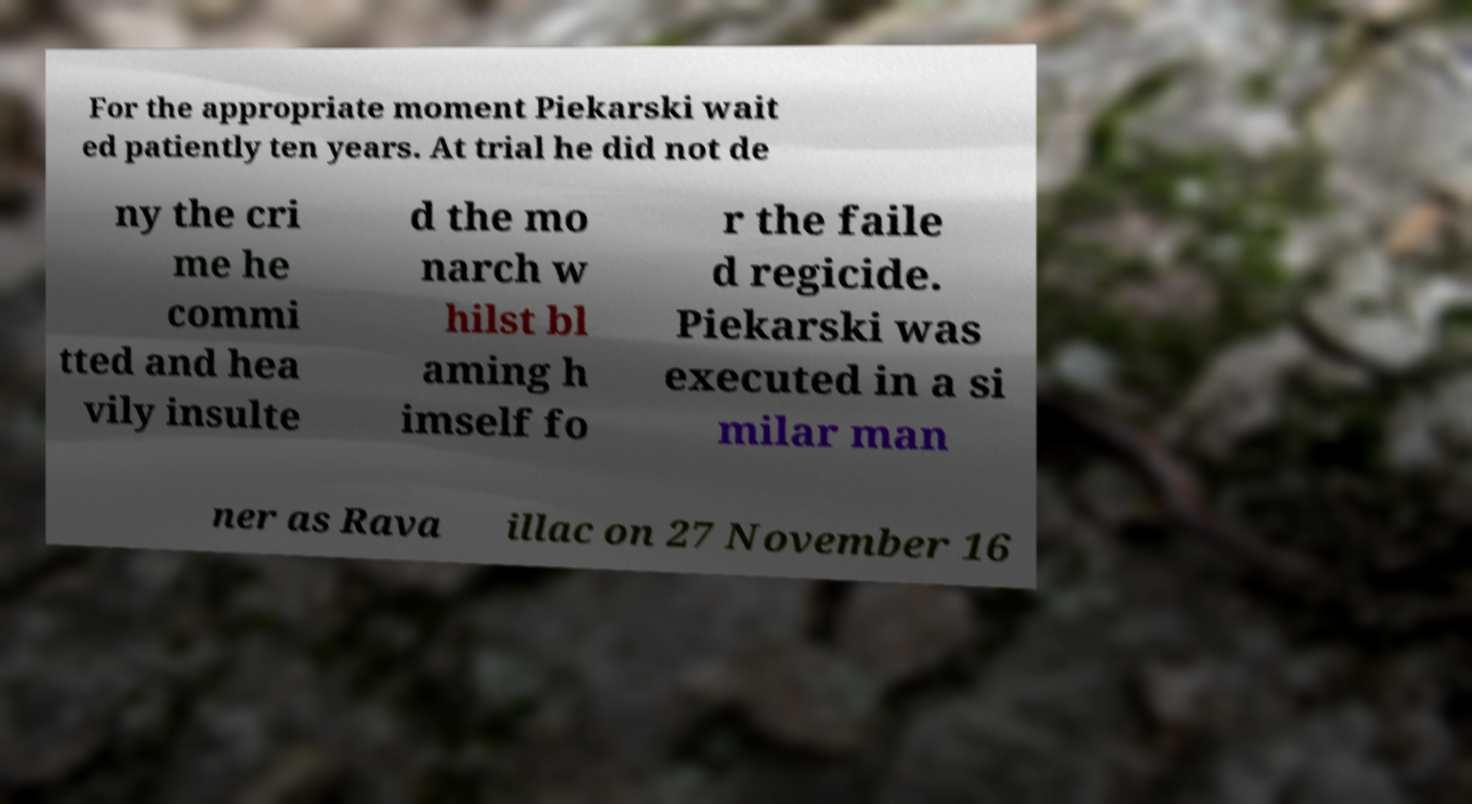For documentation purposes, I need the text within this image transcribed. Could you provide that? For the appropriate moment Piekarski wait ed patiently ten years. At trial he did not de ny the cri me he commi tted and hea vily insulte d the mo narch w hilst bl aming h imself fo r the faile d regicide. Piekarski was executed in a si milar man ner as Rava illac on 27 November 16 